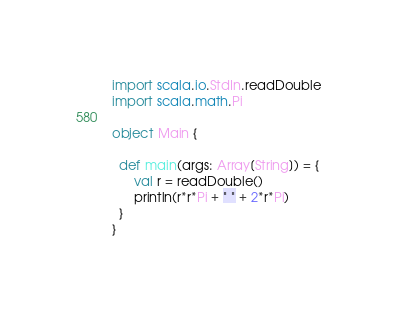Convert code to text. <code><loc_0><loc_0><loc_500><loc_500><_Scala_>import scala.io.StdIn.readDouble
import scala.math.Pi

object Main {

  def main(args: Array[String]) = {
      val r = readDouble()
      println(r*r*Pi + " " + 2*r*Pi)
  }
}</code> 